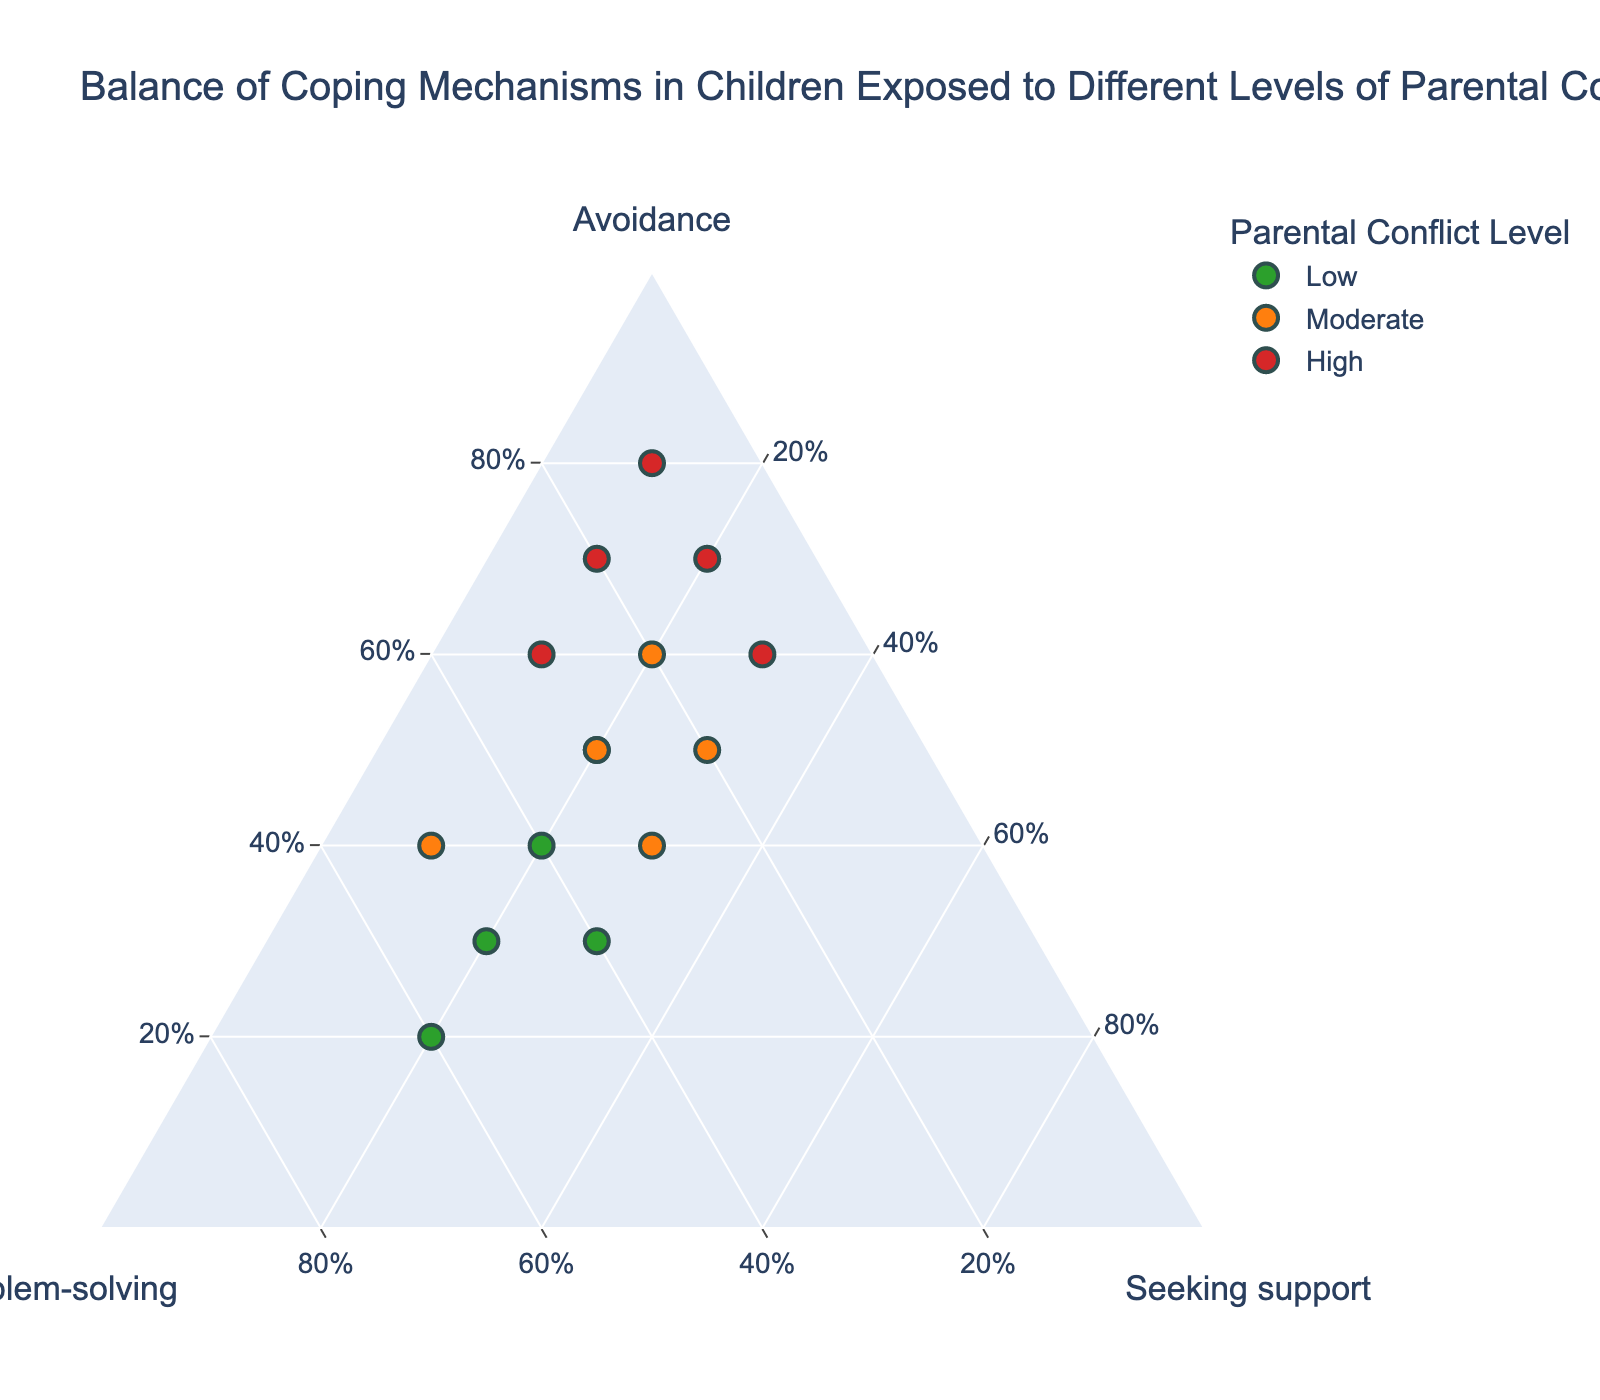what are the three coping mechanisms represented in the plot? The plot features three coping mechanisms: Avoidance, Problem-solving, and Seeking support. These are represented by the axes of the ternary plot.
Answer: Avoidance, Problem-solving, Seeking support How is parental conflict level distinguished in the plot? The parental conflict level is differentiated by color. Low conflict is green, moderate conflict is orange, and high conflict is red.
Answer: By color Which child uses the highest percentage of avoidance coping mechanism? The plot shows that Isabella uses the highest percentage of avoidance, at 80%. This can be identified by looking at the leftmost apex of the ternary plot.
Answer: Isabella What is the title of the plot? The title of the plot, displayed at the top, is "Balance of Coping Mechanisms in Children Exposed to Different Levels of Parental Conflict".
Answer: Balance of Coping Mechanisms in Children Exposed to Different Levels of Parental Conflict Which children exhibit a coping mechanism balance of approximately 40% problem-solving and 20% avoidance in low parental conflict? Both Emma and Liam in the low parental conflict level exhibit this balance, noticeable by their positions near these values on the axes.
Answer: Emma, Liam Among children experiencing high parental conflict, who shows the least reliance on seeking support? Isabella shows the least reliance on seeking support among children experiencing high parental conflict, with only 10% in Seeking support.
Answer: Isabella Compare the average avoidance coping mechanism percentages across low, moderate, and high parental conflict levels. Calculate the averages by summing the avoidance percentages for each conflict level and dividing by the number of children in each group. 
Low: (0.3 + 0.4 + 0.2 + 0.5 + 0.3)/5 = 0.34, 
Moderate: (0.5 + 0.4 + 0.6 + 0.5 + 0.2)/5 = 0.44, 
High: (0.7 + 0.6 + 0.8 + 0.7 + 0.6)/5 = 0.68
Answer: Low: 34%, Moderate: 44%, High: 68% Would a child in moderate parental conflict with a roughly 50% problem-solving strategy be closer to the 'Problem-solving' or 'Seeking support' apex? For a child in moderate parental conflict using roughly 50% problem-solving, they would be nearer to the 'Problem-solving' apex since this value is significantly higher than the ones on the Seeking support and Avoidance axes.
Answer: Problem-solving How many children use roughly the same balance of problem-solving and avoidance in moderate parental conflict levels? By examining the positions along the axes, three children (Noah, Olivia, and Harper) in moderate parental conflict levels use a roughly equal balance of problem-solving and avoidance.
Answer: Three children 